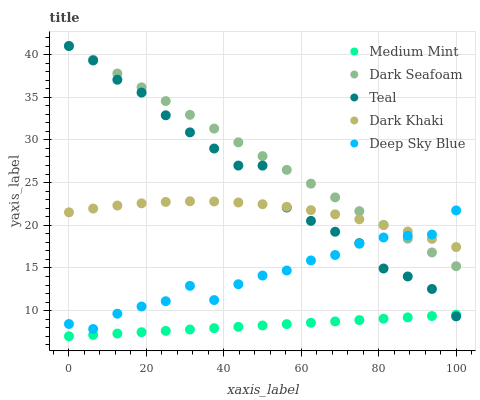Does Medium Mint have the minimum area under the curve?
Answer yes or no. Yes. Does Dark Seafoam have the maximum area under the curve?
Answer yes or no. Yes. Does Dark Khaki have the minimum area under the curve?
Answer yes or no. No. Does Dark Khaki have the maximum area under the curve?
Answer yes or no. No. Is Medium Mint the smoothest?
Answer yes or no. Yes. Is Teal the roughest?
Answer yes or no. Yes. Is Dark Khaki the smoothest?
Answer yes or no. No. Is Dark Khaki the roughest?
Answer yes or no. No. Does Medium Mint have the lowest value?
Answer yes or no. Yes. Does Dark Seafoam have the lowest value?
Answer yes or no. No. Does Teal have the highest value?
Answer yes or no. Yes. Does Dark Khaki have the highest value?
Answer yes or no. No. Is Medium Mint less than Dark Khaki?
Answer yes or no. Yes. Is Deep Sky Blue greater than Medium Mint?
Answer yes or no. Yes. Does Dark Seafoam intersect Teal?
Answer yes or no. Yes. Is Dark Seafoam less than Teal?
Answer yes or no. No. Is Dark Seafoam greater than Teal?
Answer yes or no. No. Does Medium Mint intersect Dark Khaki?
Answer yes or no. No. 